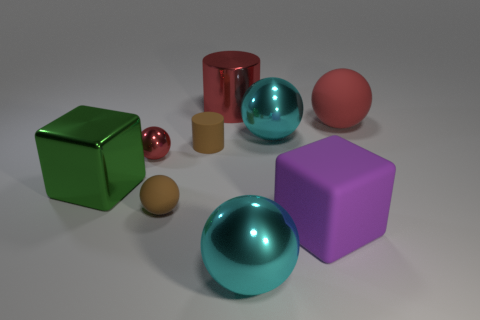There is a brown thing that is made of the same material as the brown cylinder; what is its shape?
Offer a terse response. Sphere. Are the large cyan thing that is behind the big green metal object and the large purple object made of the same material?
Provide a short and direct response. No. What is the tiny ball on the right side of the small metallic sphere made of?
Make the answer very short. Rubber. What size is the brown thing that is behind the tiny thing that is in front of the small red ball?
Ensure brevity in your answer.  Small. What number of red cylinders have the same size as the purple rubber object?
Offer a very short reply. 1. Does the tiny cylinder behind the tiny shiny thing have the same color as the rubber ball in front of the red rubber ball?
Your response must be concise. Yes. There is a red cylinder; are there any big objects in front of it?
Provide a short and direct response. Yes. What is the color of the ball that is on the left side of the purple block and behind the brown cylinder?
Keep it short and to the point. Cyan. Are there any large things that have the same color as the small shiny thing?
Ensure brevity in your answer.  Yes. Is the material of the cube on the left side of the large purple block the same as the small object that is in front of the green object?
Your response must be concise. No. 